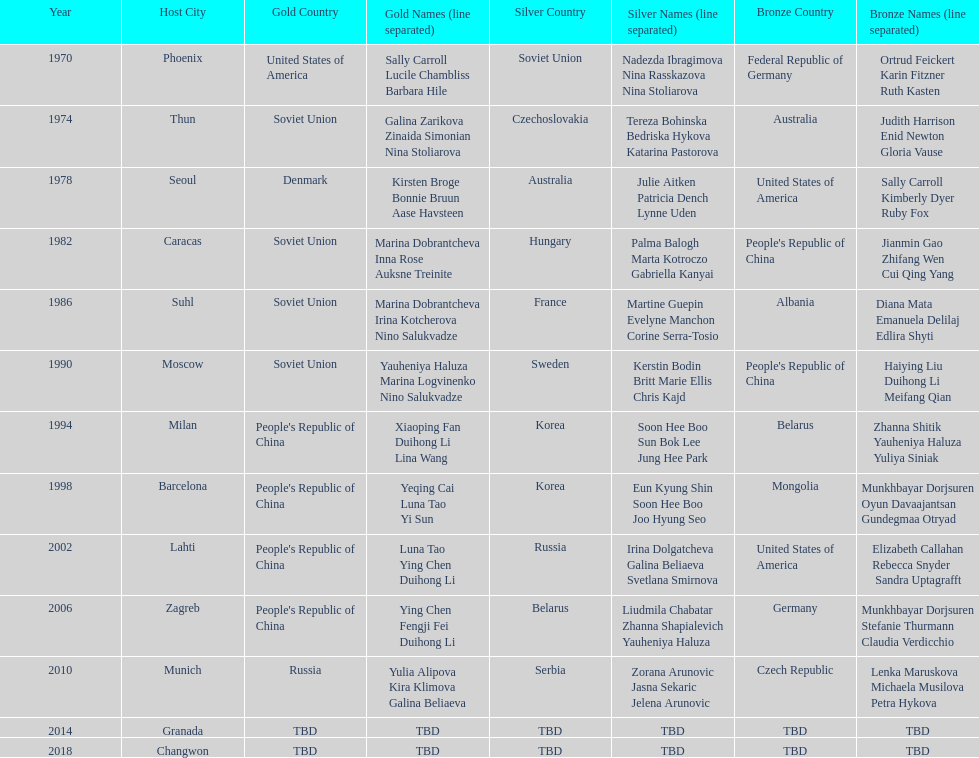What are the total number of times the soviet union is listed under the gold column? 4. 